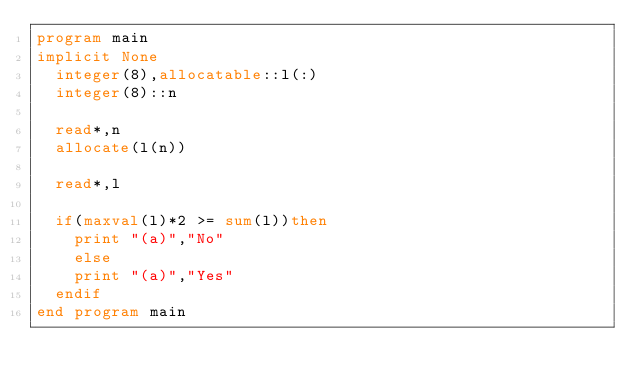Convert code to text. <code><loc_0><loc_0><loc_500><loc_500><_FORTRAN_>program main
implicit None
	integer(8),allocatable::l(:)
	integer(8)::n
	
	read*,n
	allocate(l(n))
	
	read*,l
	
	if(maxval(l)*2 >= sum(l))then
		print "(a)","No"
		else
		print "(a)","Yes"
	endif
end program main
</code> 